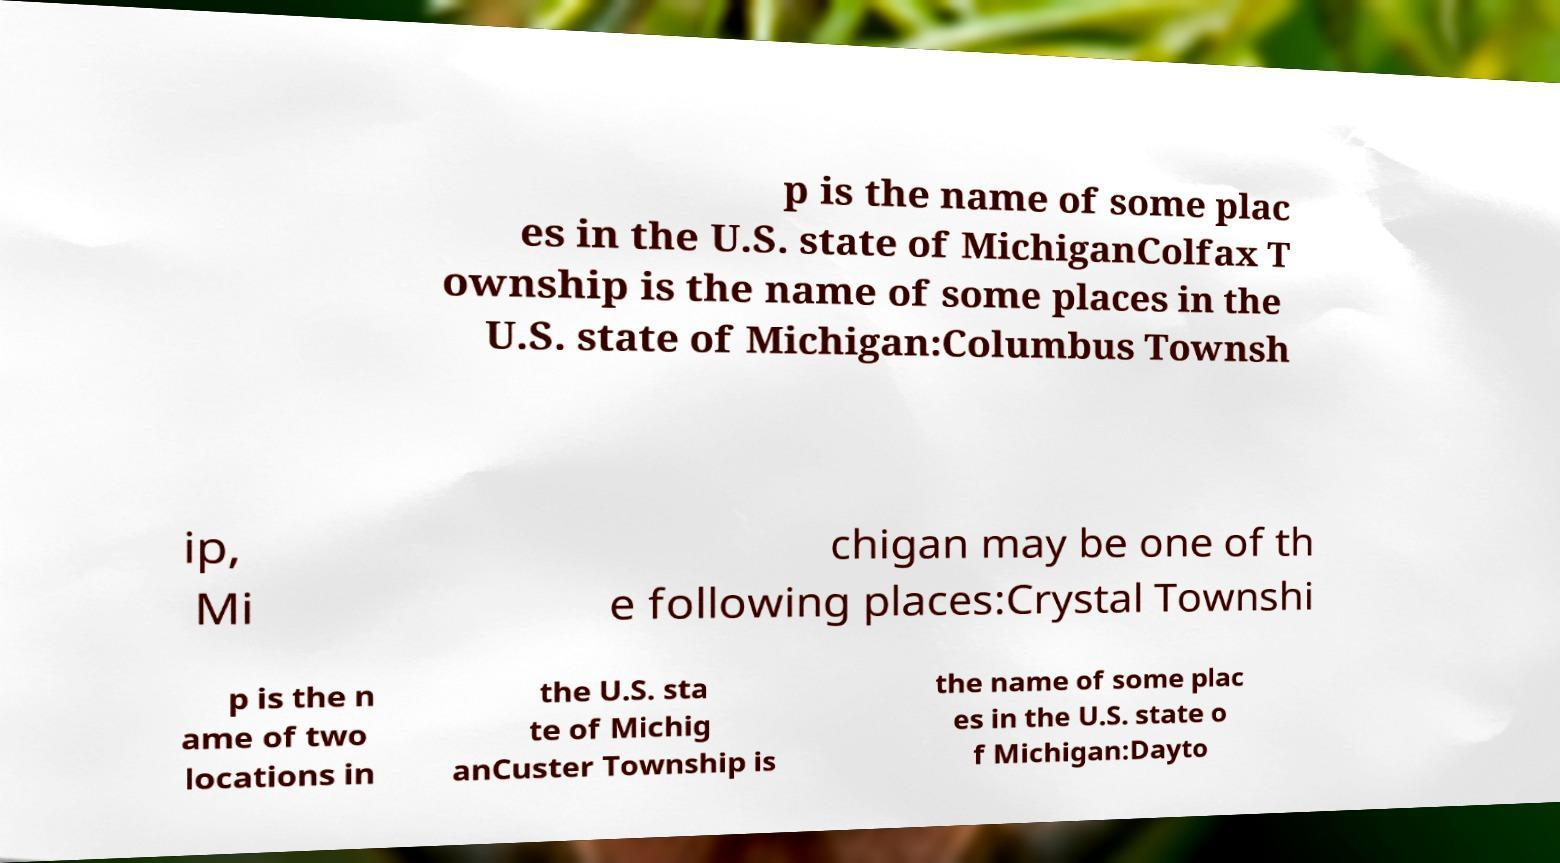For documentation purposes, I need the text within this image transcribed. Could you provide that? p is the name of some plac es in the U.S. state of MichiganColfax T ownship is the name of some places in the U.S. state of Michigan:Columbus Townsh ip, Mi chigan may be one of th e following places:Crystal Townshi p is the n ame of two locations in the U.S. sta te of Michig anCuster Township is the name of some plac es in the U.S. state o f Michigan:Dayto 